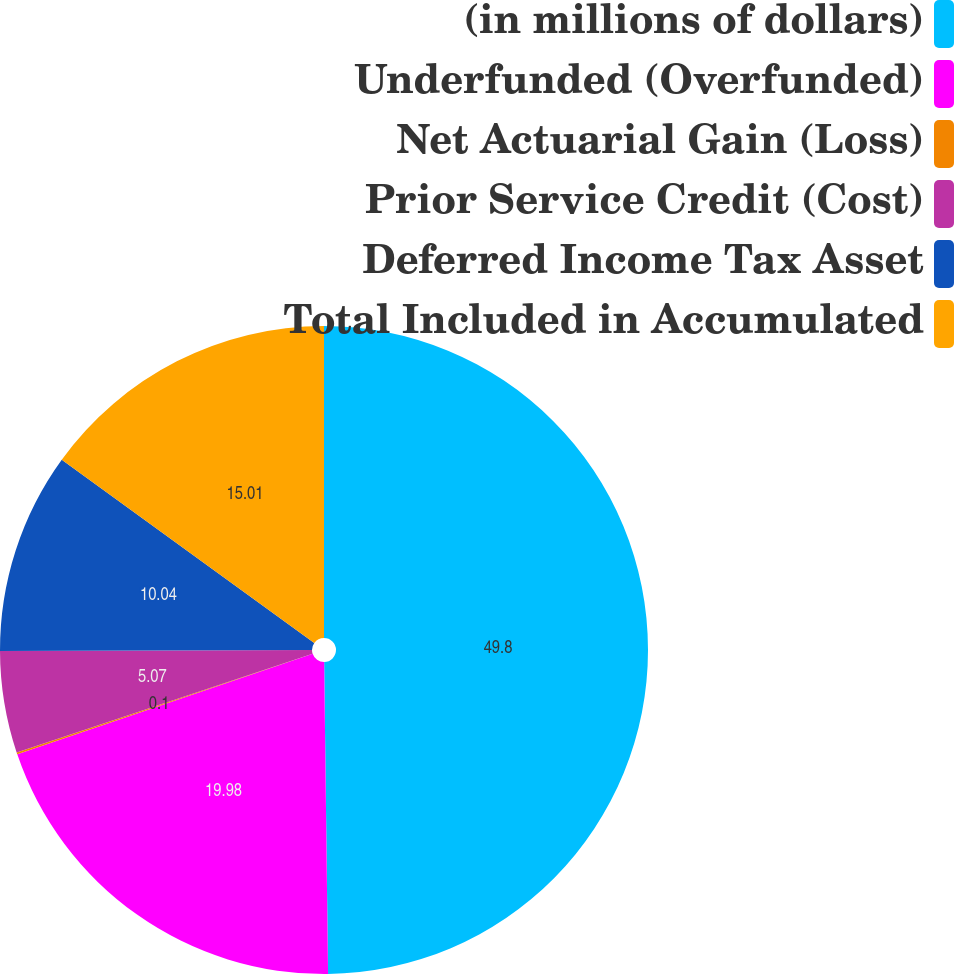Convert chart to OTSL. <chart><loc_0><loc_0><loc_500><loc_500><pie_chart><fcel>(in millions of dollars)<fcel>Underfunded (Overfunded)<fcel>Net Actuarial Gain (Loss)<fcel>Prior Service Credit (Cost)<fcel>Deferred Income Tax Asset<fcel>Total Included in Accumulated<nl><fcel>49.8%<fcel>19.98%<fcel>0.1%<fcel>5.07%<fcel>10.04%<fcel>15.01%<nl></chart> 